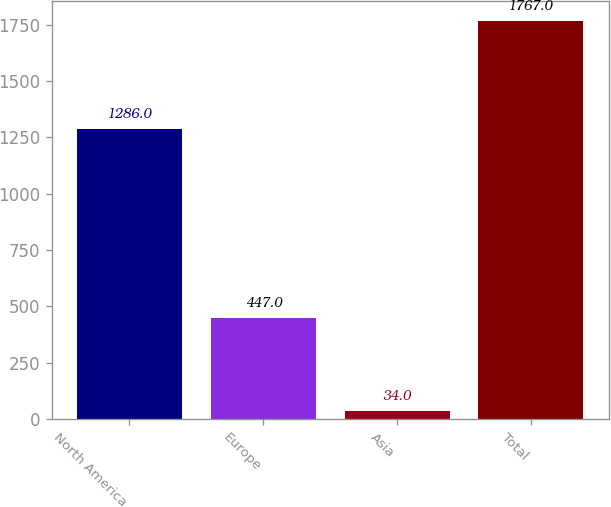<chart> <loc_0><loc_0><loc_500><loc_500><bar_chart><fcel>North America<fcel>Europe<fcel>Asia<fcel>Total<nl><fcel>1286<fcel>447<fcel>34<fcel>1767<nl></chart> 